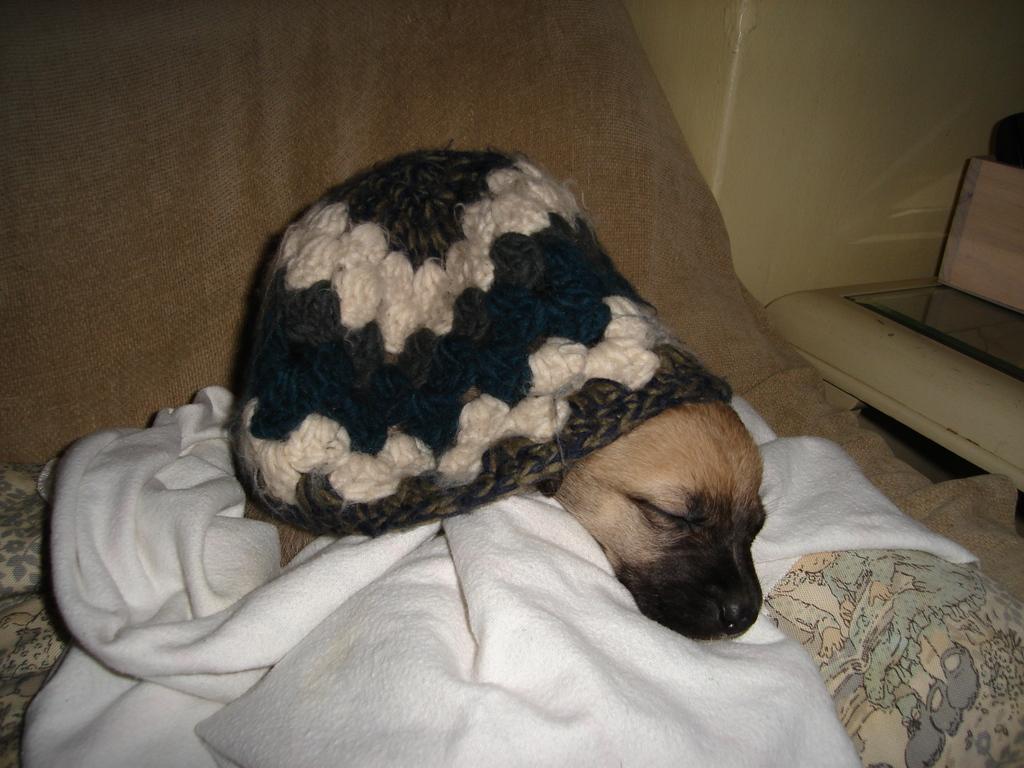Can you describe this image briefly? In this picture we can see a dog, cap, cloth, bed and in the background we can see a wall and some objects. 